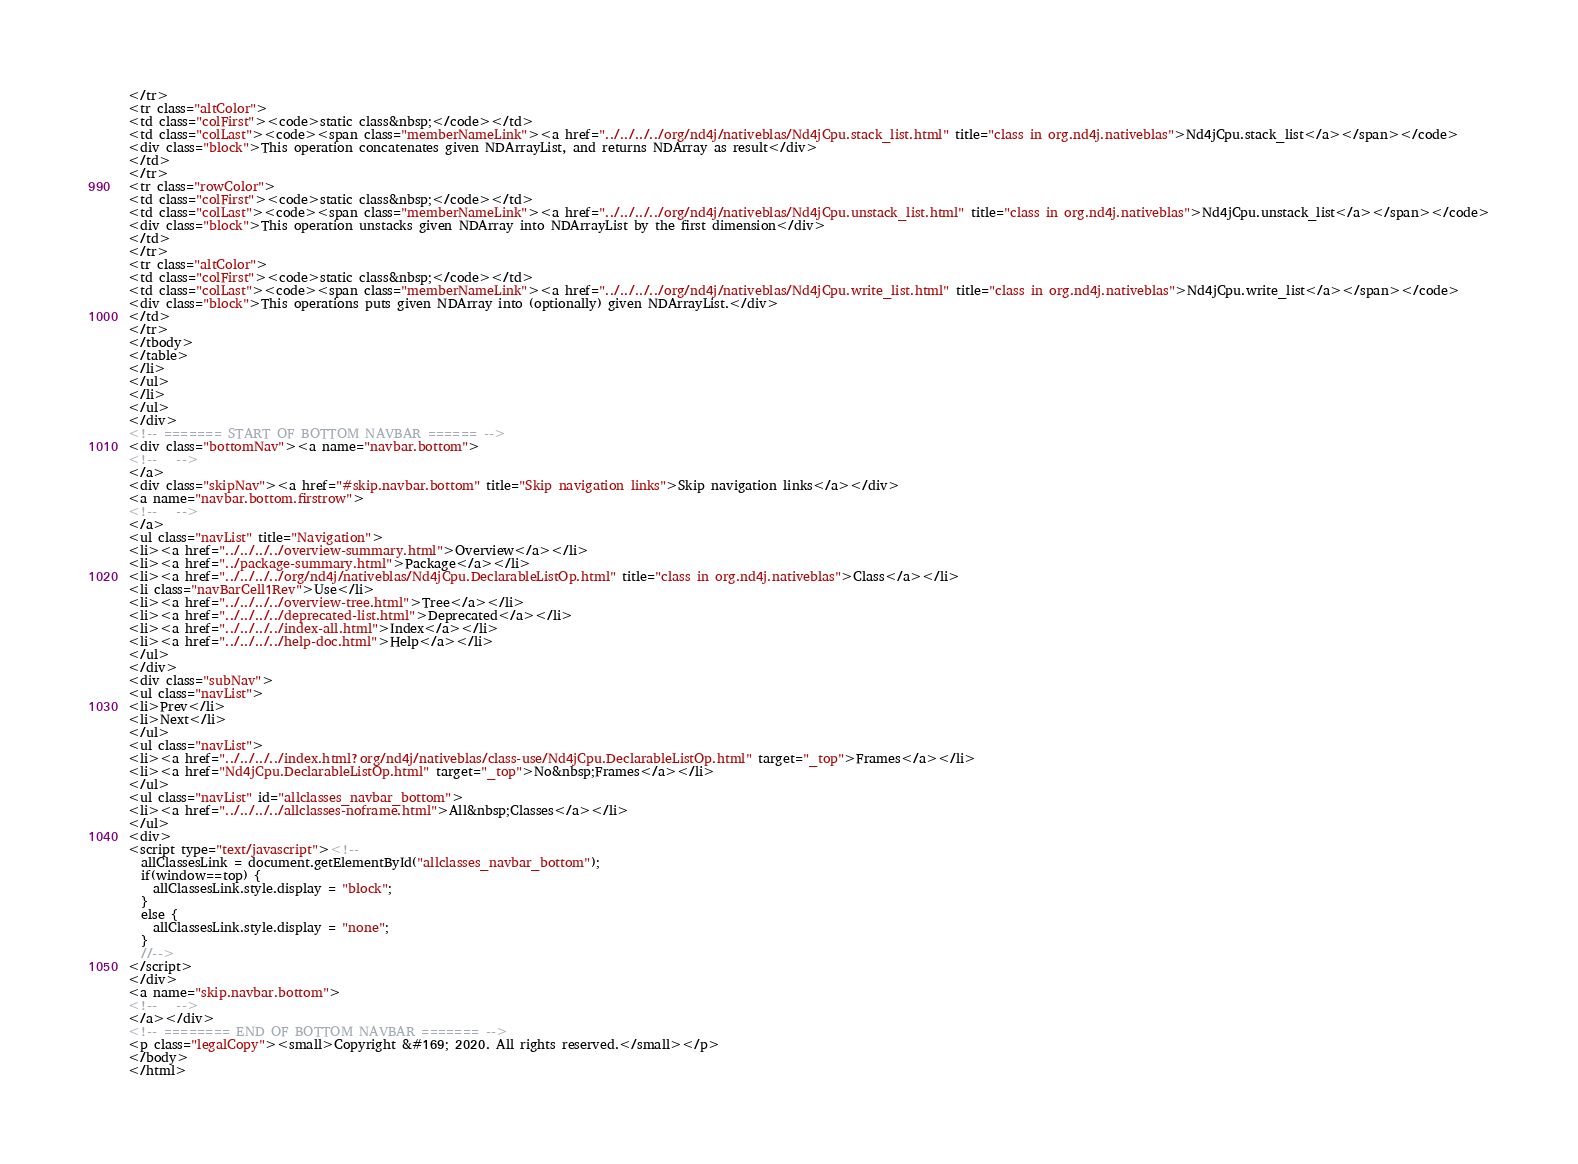Convert code to text. <code><loc_0><loc_0><loc_500><loc_500><_HTML_></tr>
<tr class="altColor">
<td class="colFirst"><code>static class&nbsp;</code></td>
<td class="colLast"><code><span class="memberNameLink"><a href="../../../../org/nd4j/nativeblas/Nd4jCpu.stack_list.html" title="class in org.nd4j.nativeblas">Nd4jCpu.stack_list</a></span></code>
<div class="block">This operation concatenates given NDArrayList, and returns NDArray as result</div>
</td>
</tr>
<tr class="rowColor">
<td class="colFirst"><code>static class&nbsp;</code></td>
<td class="colLast"><code><span class="memberNameLink"><a href="../../../../org/nd4j/nativeblas/Nd4jCpu.unstack_list.html" title="class in org.nd4j.nativeblas">Nd4jCpu.unstack_list</a></span></code>
<div class="block">This operation unstacks given NDArray into NDArrayList by the first dimension</div>
</td>
</tr>
<tr class="altColor">
<td class="colFirst"><code>static class&nbsp;</code></td>
<td class="colLast"><code><span class="memberNameLink"><a href="../../../../org/nd4j/nativeblas/Nd4jCpu.write_list.html" title="class in org.nd4j.nativeblas">Nd4jCpu.write_list</a></span></code>
<div class="block">This operations puts given NDArray into (optionally) given NDArrayList.</div>
</td>
</tr>
</tbody>
</table>
</li>
</ul>
</li>
</ul>
</div>
<!-- ======= START OF BOTTOM NAVBAR ====== -->
<div class="bottomNav"><a name="navbar.bottom">
<!--   -->
</a>
<div class="skipNav"><a href="#skip.navbar.bottom" title="Skip navigation links">Skip navigation links</a></div>
<a name="navbar.bottom.firstrow">
<!--   -->
</a>
<ul class="navList" title="Navigation">
<li><a href="../../../../overview-summary.html">Overview</a></li>
<li><a href="../package-summary.html">Package</a></li>
<li><a href="../../../../org/nd4j/nativeblas/Nd4jCpu.DeclarableListOp.html" title="class in org.nd4j.nativeblas">Class</a></li>
<li class="navBarCell1Rev">Use</li>
<li><a href="../../../../overview-tree.html">Tree</a></li>
<li><a href="../../../../deprecated-list.html">Deprecated</a></li>
<li><a href="../../../../index-all.html">Index</a></li>
<li><a href="../../../../help-doc.html">Help</a></li>
</ul>
</div>
<div class="subNav">
<ul class="navList">
<li>Prev</li>
<li>Next</li>
</ul>
<ul class="navList">
<li><a href="../../../../index.html?org/nd4j/nativeblas/class-use/Nd4jCpu.DeclarableListOp.html" target="_top">Frames</a></li>
<li><a href="Nd4jCpu.DeclarableListOp.html" target="_top">No&nbsp;Frames</a></li>
</ul>
<ul class="navList" id="allclasses_navbar_bottom">
<li><a href="../../../../allclasses-noframe.html">All&nbsp;Classes</a></li>
</ul>
<div>
<script type="text/javascript"><!--
  allClassesLink = document.getElementById("allclasses_navbar_bottom");
  if(window==top) {
    allClassesLink.style.display = "block";
  }
  else {
    allClassesLink.style.display = "none";
  }
  //-->
</script>
</div>
<a name="skip.navbar.bottom">
<!--   -->
</a></div>
<!-- ======== END OF BOTTOM NAVBAR ======= -->
<p class="legalCopy"><small>Copyright &#169; 2020. All rights reserved.</small></p>
</body>
</html>
</code> 